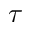<formula> <loc_0><loc_0><loc_500><loc_500>\tau</formula> 